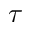<formula> <loc_0><loc_0><loc_500><loc_500>\tau</formula> 